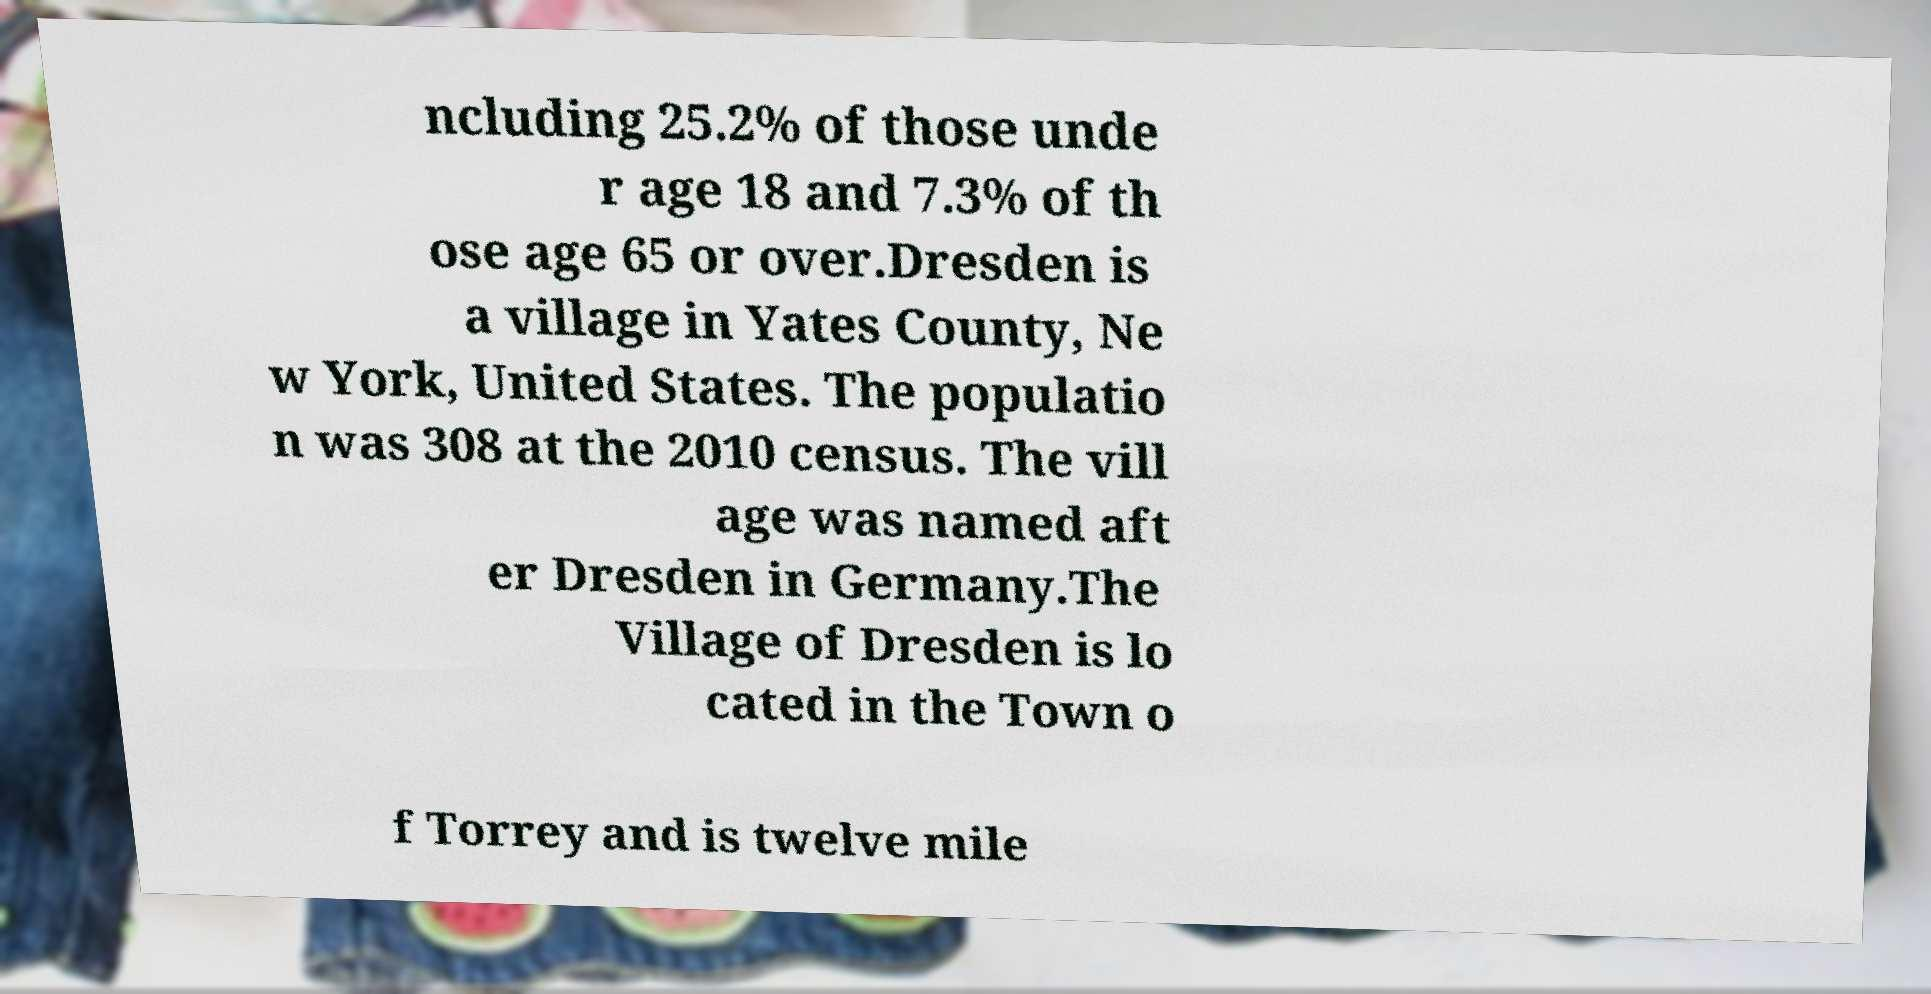Can you accurately transcribe the text from the provided image for me? ncluding 25.2% of those unde r age 18 and 7.3% of th ose age 65 or over.Dresden is a village in Yates County, Ne w York, United States. The populatio n was 308 at the 2010 census. The vill age was named aft er Dresden in Germany.The Village of Dresden is lo cated in the Town o f Torrey and is twelve mile 